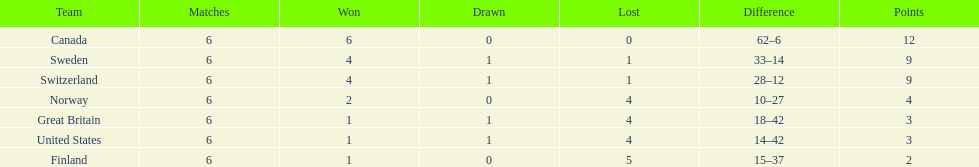Which country finished below the united states? Finland. 